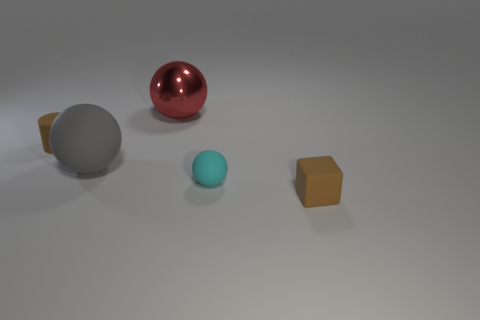Does the rubber block have the same size as the sphere to the left of the big shiny object?
Keep it short and to the point. No. There is a big red shiny object left of the small brown block; what shape is it?
Give a very brief answer. Sphere. Is there a rubber thing left of the tiny brown thing in front of the tiny brown rubber thing behind the tiny brown matte block?
Give a very brief answer. Yes. There is a red object that is the same shape as the big gray thing; what is it made of?
Keep it short and to the point. Metal. Are there any other things that have the same material as the large red sphere?
Make the answer very short. No. What number of cubes are metal objects or large gray things?
Offer a terse response. 0. There is a object that is in front of the small cyan ball; is it the same size as the cyan object on the right side of the matte cylinder?
Ensure brevity in your answer.  Yes. There is a brown object in front of the rubber sphere on the left side of the tiny ball; what is it made of?
Give a very brief answer. Rubber. Are there fewer brown matte cylinders that are behind the big rubber object than brown rubber cubes?
Your answer should be compact. No. The small cyan thing that is made of the same material as the large gray sphere is what shape?
Offer a terse response. Sphere. 